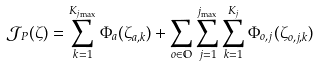<formula> <loc_0><loc_0><loc_500><loc_500>\mathcal { J } _ { P } ( \zeta ) = \sum _ { k = 1 } ^ { K _ { j _ { \max } } } \Phi _ { a } ( \zeta _ { a , k } ) + \sum _ { o \in \mathbb { O } } \sum _ { j = 1 } ^ { j _ { \max } } \sum _ { k = 1 } ^ { K _ { j } } \Phi _ { o , j } ( \zeta _ { o , j , k } )</formula> 